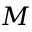<formula> <loc_0><loc_0><loc_500><loc_500>M</formula> 